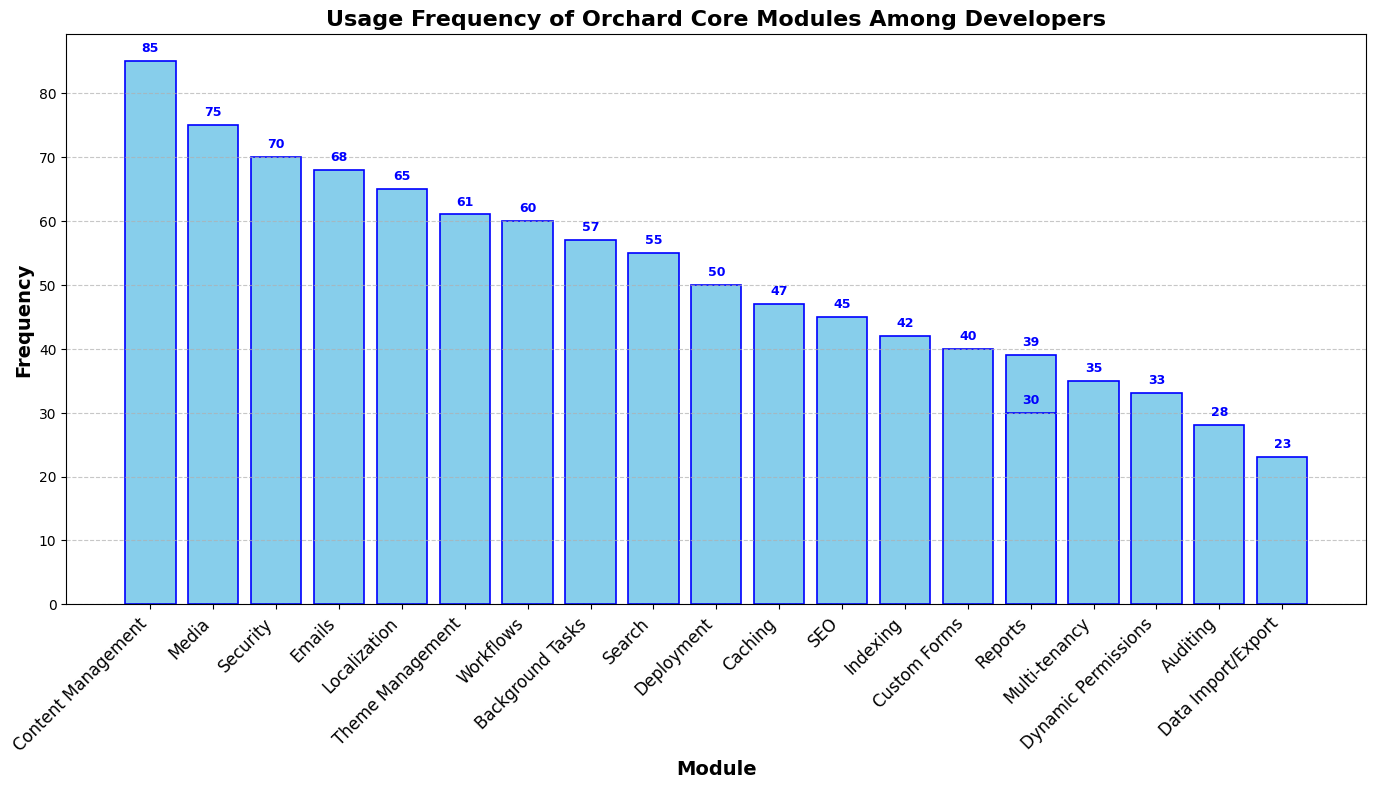Which Orchard Core module has the highest usage frequency among developers? The bar representing the "Content Management" module is the tallest, indicating it has the highest frequency.
Answer: Content Management Which Orchard Core module has the lowest usage frequency among developers? The shortest bar is for the "Data Import/Export" module, which indicates the lowest frequency.
Answer: Data Import/Export What is the total usage frequency for the top three most frequent modules? The frequencies for the top three modules are: Content Management (85), Media (75), and Security (70). Summing them gives 85 + 75 + 70 = 230.
Answer: 230 How does the usage frequency of the "Search" module compare to the "SEO" module? The frequency for "Search" is 55 and for "SEO" is 45. The "Search" module has a higher usage frequency than the "SEO" module by 55 - 45 = 10.
Answer: Search is higher by 10 How many modules have a usage frequency greater than 60? The modules with frequencies greater than 60 are: Content Management (85), Media (75), Security (70), Theme Management (61), and Emails (68). There are 5 such modules.
Answer: 5 Which modules have a usage frequency between 50 and 60? The modules within this range are: Workflows (60), Search (55), and Background Tasks (57). There are 3 modules in this range.
Answer: Workflows, Search, Background Tasks What is the average usage frequency for the modules in the list? To find the average, sum all the frequencies and divide by the number of modules. The total sum of frequencies is 968, and there are 18 modules, so 968 / 18 ≈ 53.78.
Answer: 53.78 By how much does the usage of the "Localization" module exceed that of the "Custom Forms" module? The frequency for "Localization" is 65, and for "Custom Forms" it is 40. The excess is 65 - 40 = 25.
Answer: 25 What is the combined usage frequency of the least frequent five modules? The frequencies for the least frequent five modules are: Data Import/Export (23), Auditing (28), Reports (30), Multi-tenancy (35), and Dynamic Permissions (33). Their total is 23 + 28 + 30 + 35 + 33 = 149.
Answer: 149 